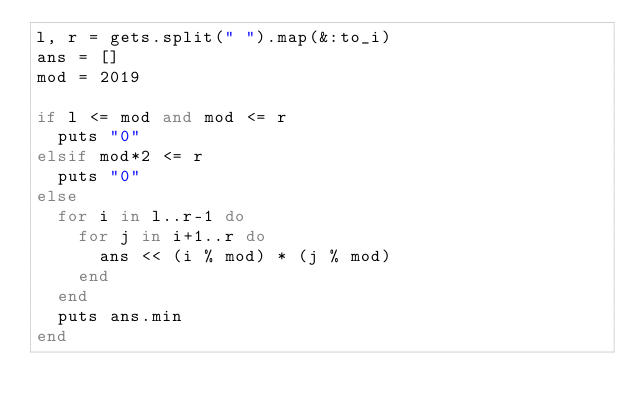<code> <loc_0><loc_0><loc_500><loc_500><_Ruby_>l, r = gets.split(" ").map(&:to_i)
ans = []
mod = 2019

if l <= mod and mod <= r
  puts "0"
elsif mod*2 <= r 
  puts "0"
else
  for i in l..r-1 do
    for j in i+1..r do
      ans << (i % mod) * (j % mod)
    end
  end
  puts ans.min
end</code> 